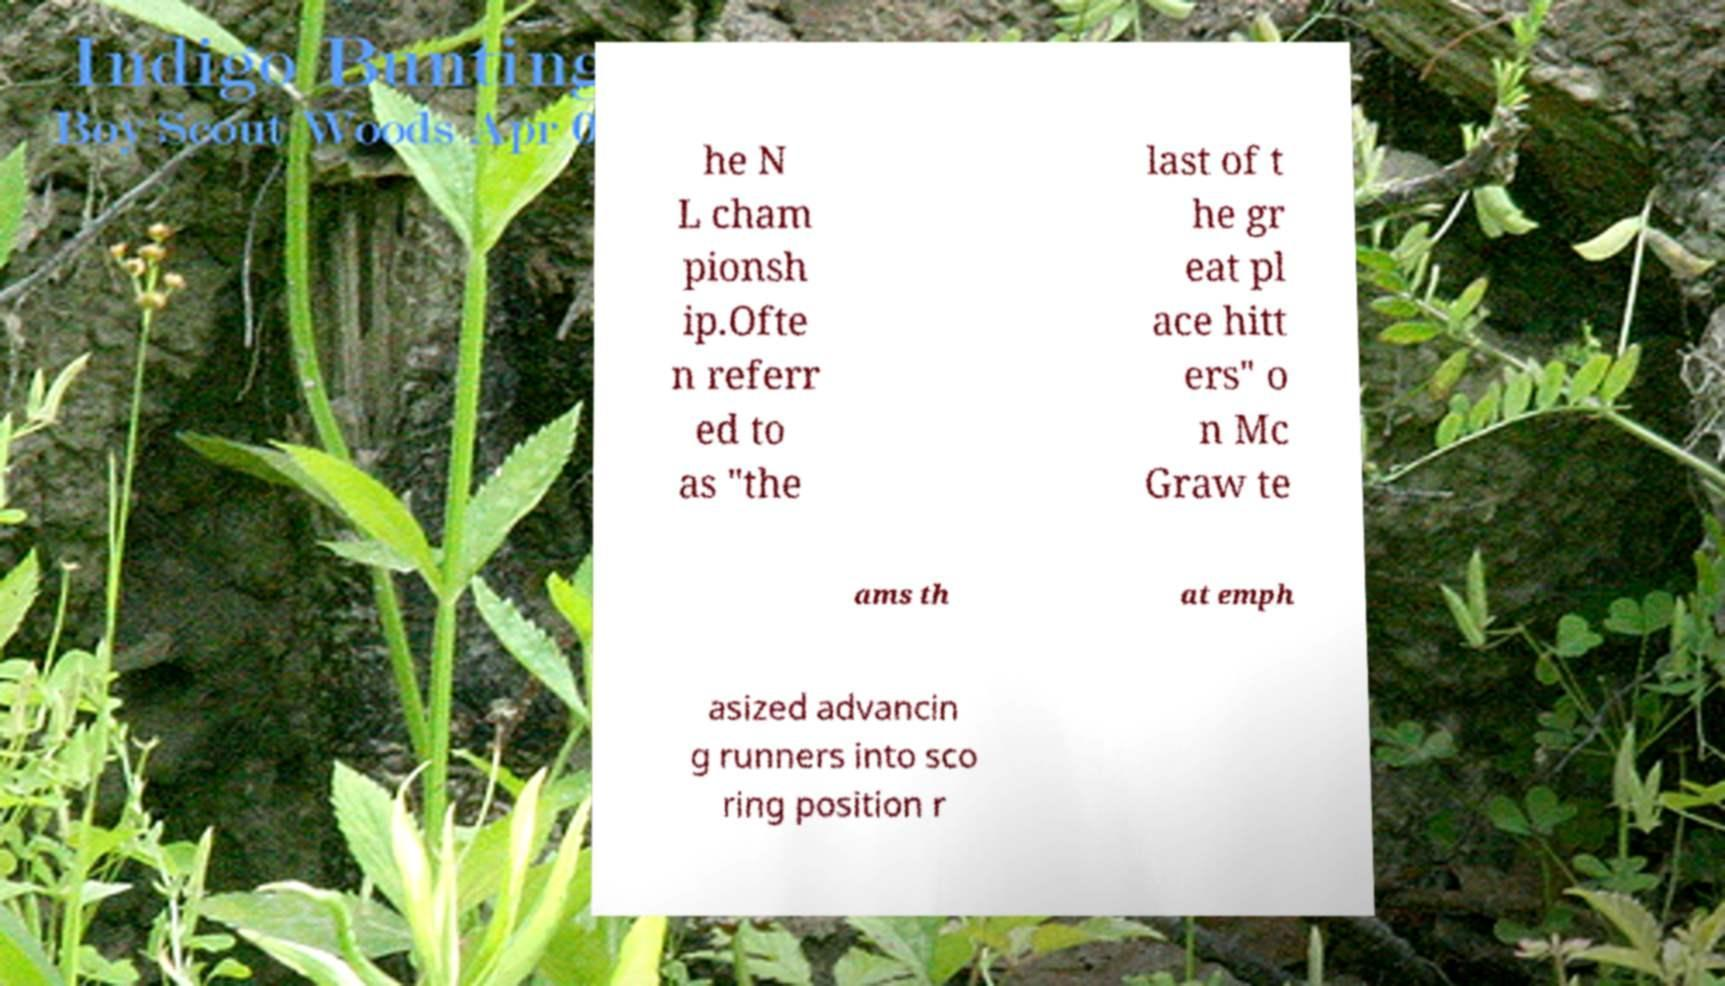Could you assist in decoding the text presented in this image and type it out clearly? he N L cham pionsh ip.Ofte n referr ed to as "the last of t he gr eat pl ace hitt ers" o n Mc Graw te ams th at emph asized advancin g runners into sco ring position r 